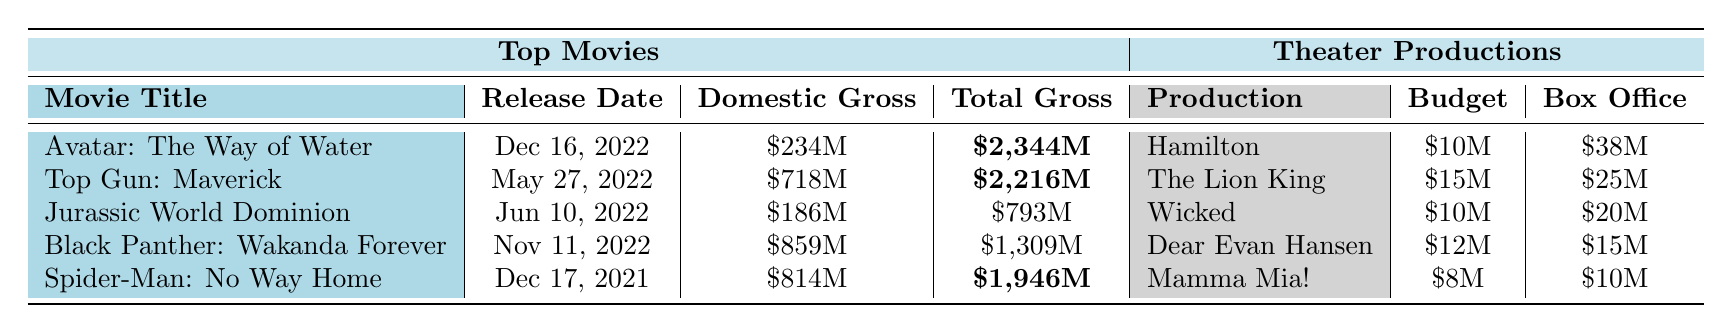What is the total gross of "Avatar: The Way of Water"? The total gross of "Avatar: The Way of Water" is listed in the table as $2,344,000,000.
Answer: $2,344,000,000 Which theater production has the highest box office earnings? The highest box office earnings in the theater productions listed is $38,000,000 for "Hamilton."
Answer: Hamilton What is the combined box office earnings of all theater productions listed? The combined box office earnings are calculated by adding up the box office values: $38M + $25M + $20M + $15M + $10M = $108M.
Answer: $108,000,000 Is the production budget for "Black Panther: Wakanda Forever" higher than that of "Jurassic World Dominion"? "Black Panther: Wakanda Forever" has a production budget of $12,000,000, while "Jurassic World Dominion" has a budget of $10,000,000, making it true that Black Panther's budget is higher.
Answer: Yes What is the average production budget of the theater productions listed? The average production budget is calculated by adding the budgets ($10M + $15M + $10M + $12M + $8M = $55M) and dividing by the number of productions (5), resulting in an average of $11M.
Answer: $11,000,000 Which movie had the highest domestic gross? The movie with the highest domestic gross is "Black Panther: Wakanda Forever," which earned $859,000,000.
Answer: $859,000,000 What is the difference in total gross between "Top Gun: Maverick" and "Spider-Man: No Way Home"? To find the difference, we subtract the total gross of "Spider-Man: No Way Home" ($1,946M) from that of "Top Gun: Maverick" ($2,216M): $2,216M - $1,946M = $270M.
Answer: $270,000,000 If you compare the box office earnings of "The Lion King" to "Dear Evan Hansen," which one is higher? "The Lion King" has earnings of $25,000,000, while "Dear Evan Hansen" has $15,000,000; thus, "The Lion King" earns more.
Answer: The Lion King What percentage of total gross from "Avatar: The Way of Water" is the box office earnings of "Hamilton"? To determine the percentage, divide Hamilton's box office ($38M) by Avatar's total gross ($2,344M) and multiply by 100: ($38M / $2,344M) * 100 ≈ 1.62%.
Answer: 1.62% Which movie has the least amount of total gross? The least amount of total gross is attributed to "Jurassic World Dominion," which earned $793,000,000.
Answer: $793,000,000 